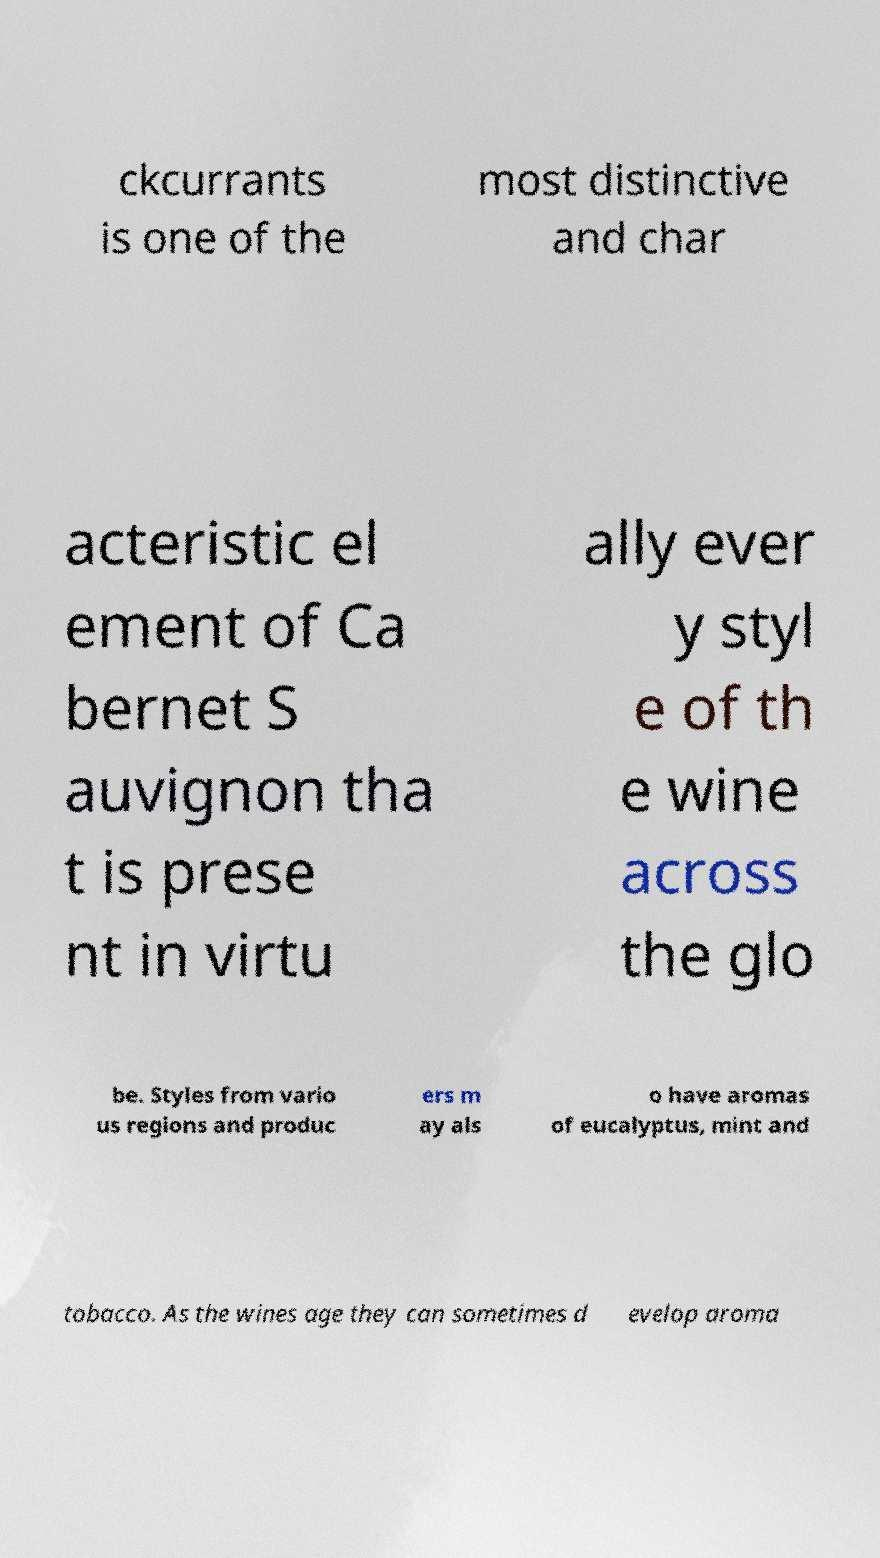Could you extract and type out the text from this image? ckcurrants is one of the most distinctive and char acteristic el ement of Ca bernet S auvignon tha t is prese nt in virtu ally ever y styl e of th e wine across the glo be. Styles from vario us regions and produc ers m ay als o have aromas of eucalyptus, mint and tobacco. As the wines age they can sometimes d evelop aroma 